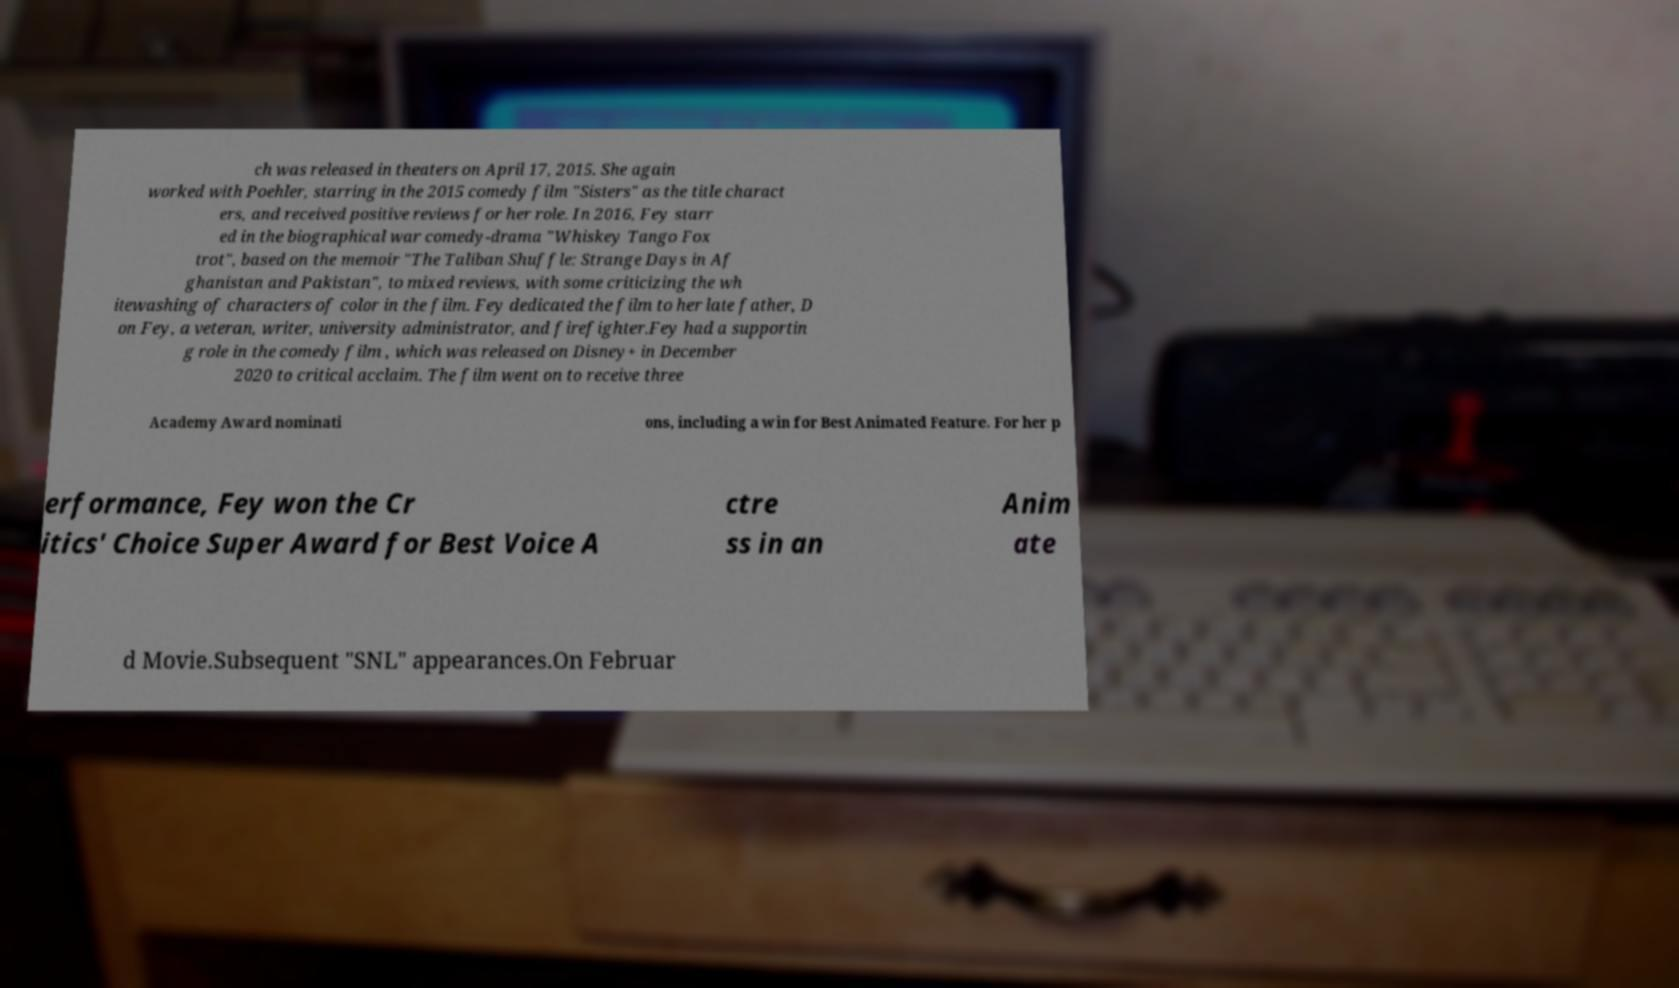What messages or text are displayed in this image? I need them in a readable, typed format. ch was released in theaters on April 17, 2015. She again worked with Poehler, starring in the 2015 comedy film "Sisters" as the title charact ers, and received positive reviews for her role. In 2016, Fey starr ed in the biographical war comedy-drama "Whiskey Tango Fox trot", based on the memoir "The Taliban Shuffle: Strange Days in Af ghanistan and Pakistan", to mixed reviews, with some criticizing the wh itewashing of characters of color in the film. Fey dedicated the film to her late father, D on Fey, a veteran, writer, university administrator, and firefighter.Fey had a supportin g role in the comedy film , which was released on Disney+ in December 2020 to critical acclaim. The film went on to receive three Academy Award nominati ons, including a win for Best Animated Feature. For her p erformance, Fey won the Cr itics' Choice Super Award for Best Voice A ctre ss in an Anim ate d Movie.Subsequent "SNL" appearances.On Februar 